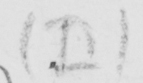What text is written in this handwritten line? ( D ) 